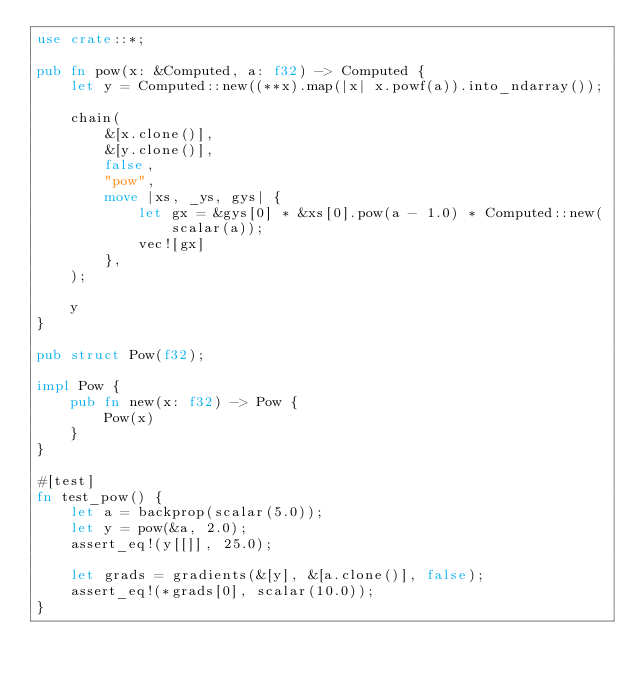<code> <loc_0><loc_0><loc_500><loc_500><_Rust_>use crate::*;

pub fn pow(x: &Computed, a: f32) -> Computed {
    let y = Computed::new((**x).map(|x| x.powf(a)).into_ndarray());

    chain(
        &[x.clone()],
        &[y.clone()],
        false,
        "pow",
        move |xs, _ys, gys| {
            let gx = &gys[0] * &xs[0].pow(a - 1.0) * Computed::new(scalar(a));
            vec![gx]
        },
    );

    y
}

pub struct Pow(f32);

impl Pow {
    pub fn new(x: f32) -> Pow {
        Pow(x)
    }
}

#[test]
fn test_pow() {
    let a = backprop(scalar(5.0));
    let y = pow(&a, 2.0);
    assert_eq!(y[[]], 25.0);

    let grads = gradients(&[y], &[a.clone()], false);
    assert_eq!(*grads[0], scalar(10.0));
}
</code> 